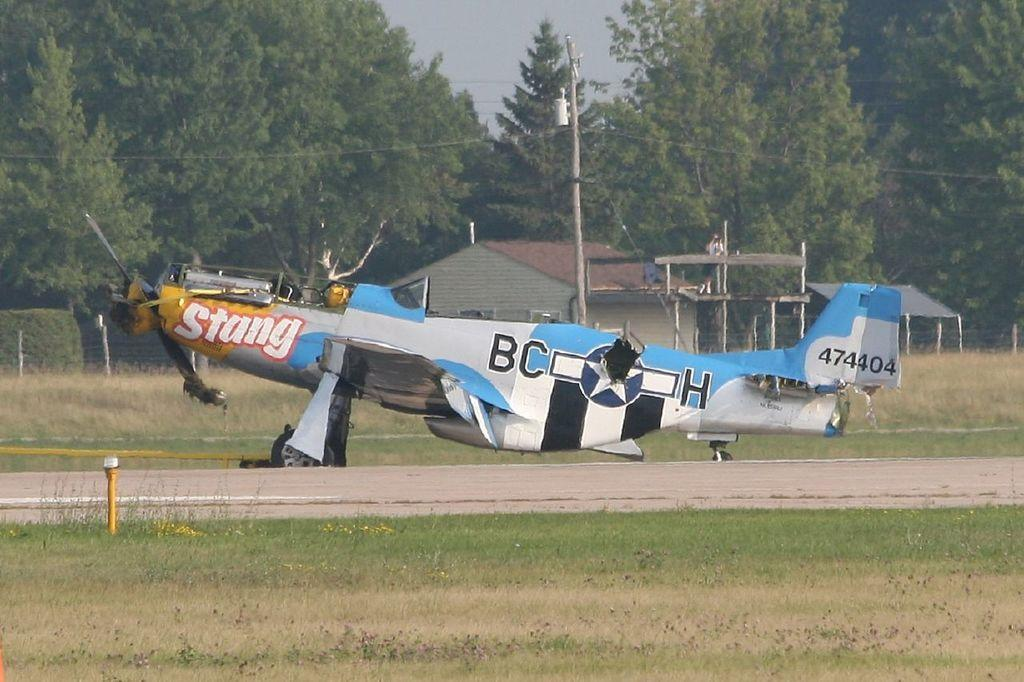What is the main subject of the image? The main subject of the image is an aircraft. Where is the aircraft located in the image? The aircraft is on the ground. What type of vegetation is present around the aircraft? There is a lot of grass around the aircraft. What can be seen in the background of the image? There is a house in the background of the image, and many trees behind the house. What color is the invention depicted in the image? There is no invention present in the image, and the color of the aircraft cannot be determined from the provided facts. 